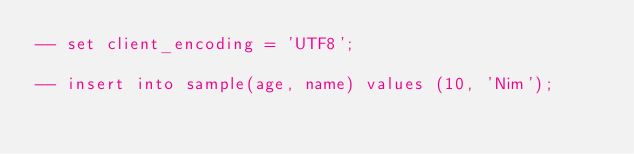<code> <loc_0><loc_0><loc_500><loc_500><_SQL_>-- set client_encoding = 'UTF8';

-- insert into sample(age, name) values (10, 'Nim');
</code> 